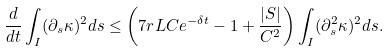Convert formula to latex. <formula><loc_0><loc_0><loc_500><loc_500>\frac { d } { d t } \int _ { I } ( \partial _ { s } \kappa ) ^ { 2 } d s \leq \left ( 7 r L C e ^ { - \delta t } - 1 + \frac { | S | } { C ^ { 2 } } \right ) \int _ { I } ( \partial _ { s } ^ { 2 } \kappa ) ^ { 2 } d s .</formula> 